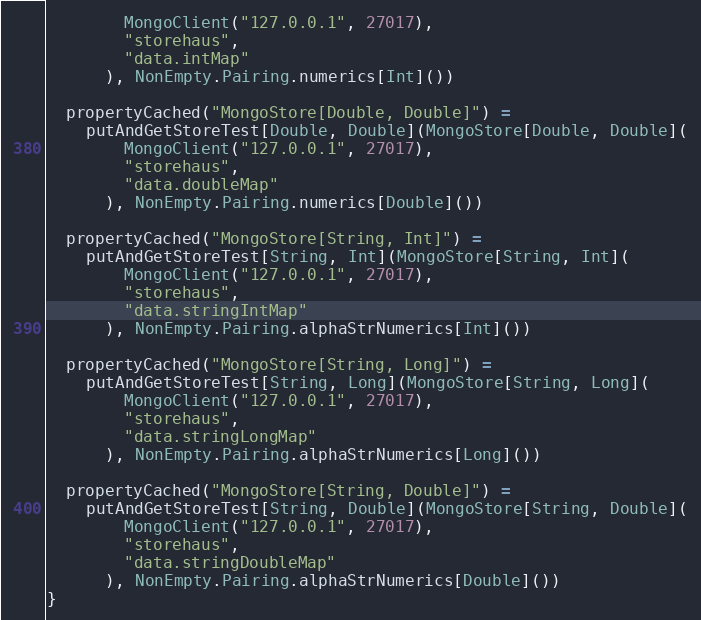<code> <loc_0><loc_0><loc_500><loc_500><_Scala_>        MongoClient("127.0.0.1", 27017),
        "storehaus",
        "data.intMap"
      ), NonEmpty.Pairing.numerics[Int]())

  propertyCached("MongoStore[Double, Double]") =
    putAndGetStoreTest[Double, Double](MongoStore[Double, Double](
        MongoClient("127.0.0.1", 27017),
        "storehaus",
        "data.doubleMap"
      ), NonEmpty.Pairing.numerics[Double]())

  propertyCached("MongoStore[String, Int]") =
    putAndGetStoreTest[String, Int](MongoStore[String, Int](
        MongoClient("127.0.0.1", 27017),
        "storehaus",
        "data.stringIntMap"
      ), NonEmpty.Pairing.alphaStrNumerics[Int]())

  propertyCached("MongoStore[String, Long]") =
    putAndGetStoreTest[String, Long](MongoStore[String, Long](
        MongoClient("127.0.0.1", 27017),
        "storehaus",
        "data.stringLongMap"
      ), NonEmpty.Pairing.alphaStrNumerics[Long]())

  propertyCached("MongoStore[String, Double]") =
    putAndGetStoreTest[String, Double](MongoStore[String, Double](
        MongoClient("127.0.0.1", 27017),
        "storehaus",
        "data.stringDoubleMap"
      ), NonEmpty.Pairing.alphaStrNumerics[Double]())
}

</code> 